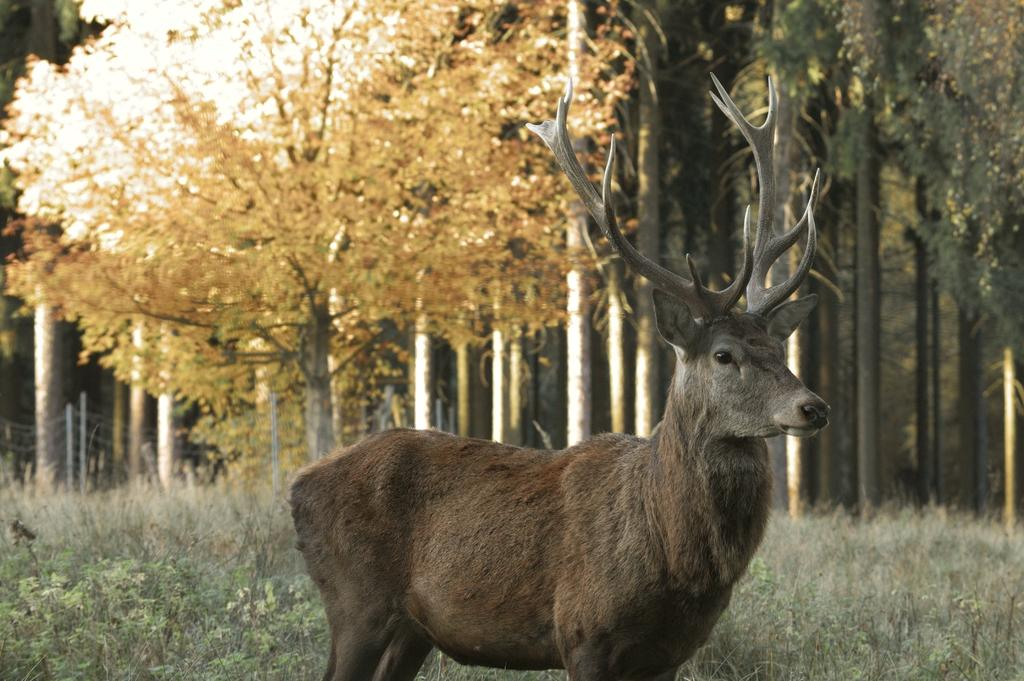What type of animal is in the image? There is an animal in the image that appears to be a deer. Where is the deer located in the image? The deer is standing in the center of the image. What can be seen behind the deer in the image? There are trees visible behind the deer. What type of vegetation is at the bottom of the image? Grass is present at the bottom of the image. What type of seed is the deer holding in its mouth in the image? There is no seed present in the image, and the deer is not holding anything in its mouth. 